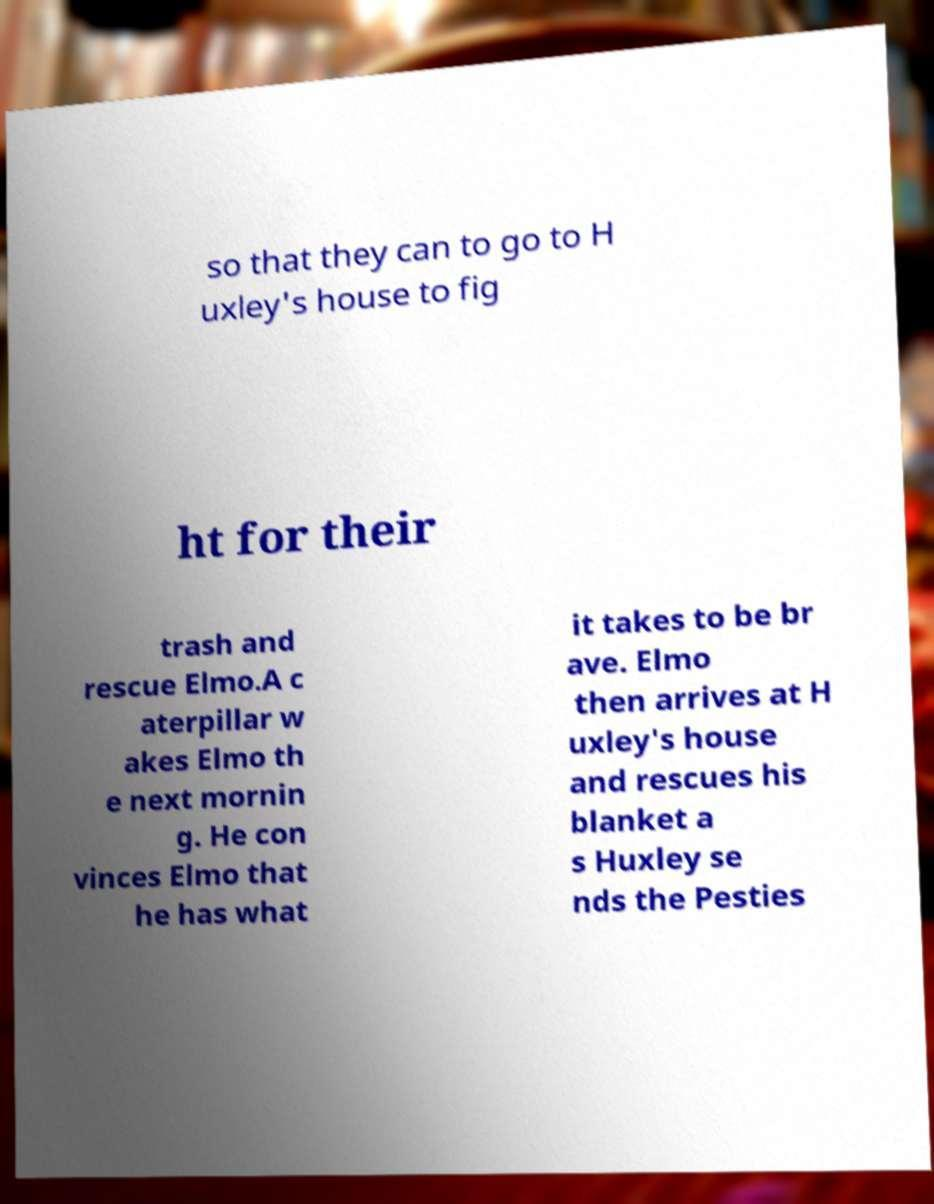Can you read and provide the text displayed in the image?This photo seems to have some interesting text. Can you extract and type it out for me? so that they can to go to H uxley's house to fig ht for their trash and rescue Elmo.A c aterpillar w akes Elmo th e next mornin g. He con vinces Elmo that he has what it takes to be br ave. Elmo then arrives at H uxley's house and rescues his blanket a s Huxley se nds the Pesties 